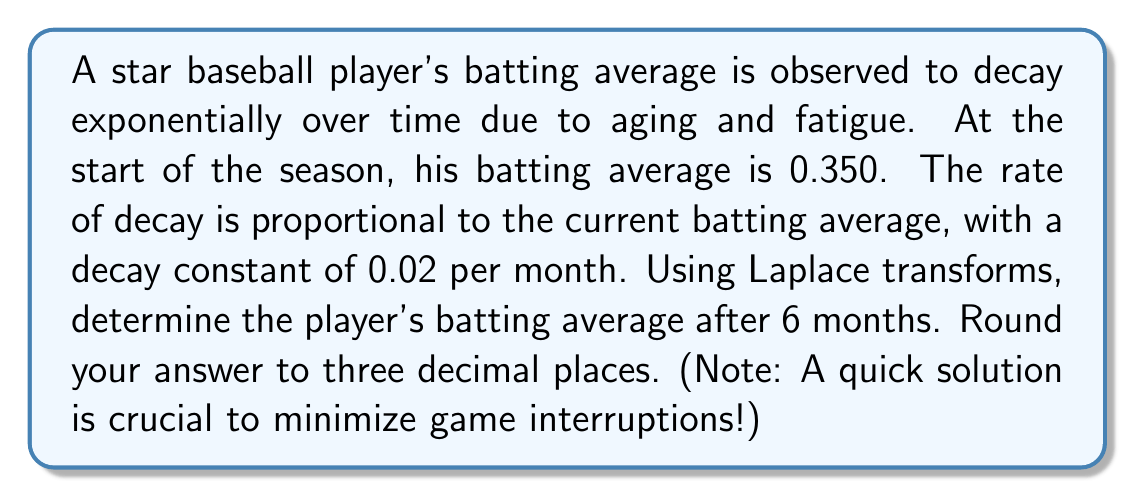Show me your answer to this math problem. Let's approach this step-by-step using Laplace transforms:

1) Let $A(t)$ be the batting average at time $t$ (in months). We're given:
   $A(0) = 0.350$
   $\frac{dA}{dt} = -0.02A$

2) This forms an initial value problem:
   $$\begin{cases}
   \frac{dA}{dt} + 0.02A = 0 \\
   A(0) = 0.350
   \end{cases}$$

3) Take the Laplace transform of both sides:
   $$\mathcal{L}\{\frac{dA}{dt}\} + 0.02\mathcal{L}\{A\} = 0$$

4) Using the Laplace transform properties:
   $$s\mathcal{L}\{A\} - A(0) + 0.02\mathcal{L}\{A\} = 0$$

5) Let $\mathcal{L}\{A\} = \bar{A}(s)$. Substituting and rearranging:
   $$s\bar{A}(s) - 0.350 + 0.02\bar{A}(s) = 0$$
   $$(s + 0.02)\bar{A}(s) = 0.350$$
   $$\bar{A}(s) = \frac{0.350}{s + 0.02}$$

6) This is in the form of $\frac{k}{s + a}$, which has the inverse Laplace transform $ke^{-at}$.

7) Therefore, the inverse Laplace transform gives us:
   $$A(t) = 0.350e^{-0.02t}$$

8) To find the batting average after 6 months, we substitute $t = 6$:
   $$A(6) = 0.350e^{-0.02(6)} = 0.350e^{-0.12} \approx 0.312$$
Answer: $0.312$ 